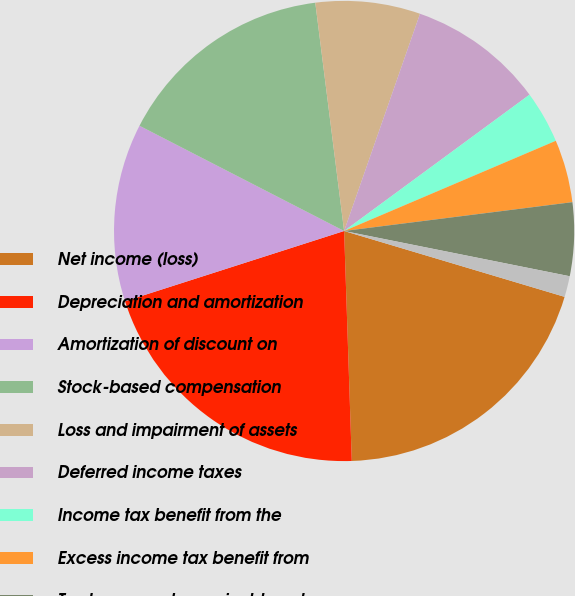Convert chart. <chart><loc_0><loc_0><loc_500><loc_500><pie_chart><fcel>Net income (loss)<fcel>Depreciation and amortization<fcel>Amortization of discount on<fcel>Stock-based compensation<fcel>Loss and impairment of assets<fcel>Deferred income taxes<fcel>Income tax benefit from the<fcel>Excess income tax benefit from<fcel>Trade accounts receivable net<fcel>In ventories<nl><fcel>19.85%<fcel>20.59%<fcel>12.5%<fcel>15.44%<fcel>7.35%<fcel>9.56%<fcel>3.68%<fcel>4.41%<fcel>5.15%<fcel>1.47%<nl></chart> 